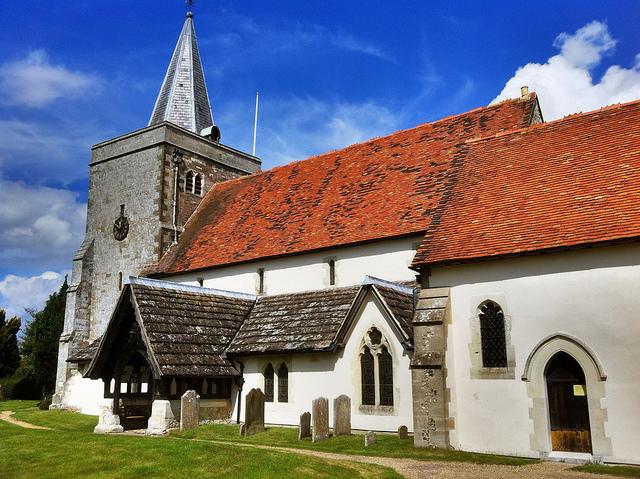Is there a clock on the church tower?
Quick response, please. Yes. Is this a church?
Concise answer only. Yes. Is this a Baptist Church?
Give a very brief answer. No. What is the color of the roof shingles?
Be succinct. Orange. 